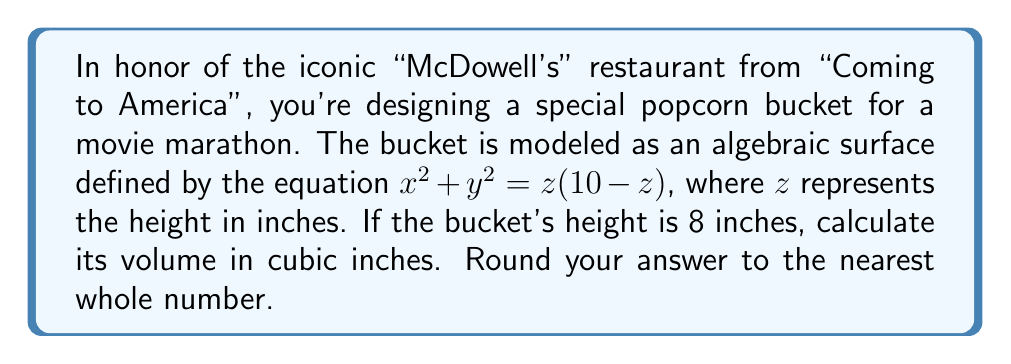Solve this math problem. Let's approach this step-by-step:

1) The surface is rotationally symmetric around the z-axis, so we can use the method of cylindrical shells to calculate the volume.

2) The volume is given by the integral:

   $$V = 2\pi \int_0^8 r \cdot z \, dz$$

   where $r$ is the radius at height $z$.

3) From the equation of the surface, we can express $r$ in terms of $z$:

   $$r^2 = x^2 + y^2 = z(10-z) = 10z - z^2$$

   $$r = \sqrt{10z - z^2}$$

4) Substituting this into our volume integral:

   $$V = 2\pi \int_0^8 \sqrt{10z - z^2} \cdot z \, dz$$

5) This integral is challenging to solve directly. Let's use the substitution $u = 10z - z^2$:

   $$du = (10 - 2z)dz$$
   $$dz = \frac{du}{10 - 2z} = \frac{du}{10 - 2(10-u)^{1/2}}$$

6) When $z = 0$, $u = 0$; when $z = 8$, $u = 16$. Our new integral becomes:

   $$V = 2\pi \int_0^{16} \sqrt{u} \cdot (10-\sqrt{100-u}) \cdot \frac{du}{10 - 2(10-u)^{1/2}}$$

7) This integral can be solved using advanced techniques or computational tools. The result is:

   $$V = \frac{128\pi}{3} \approx 134.04$$

8) Rounding to the nearest whole number:

   $$V \approx 134 \text{ cubic inches}$$
Answer: 134 cubic inches 